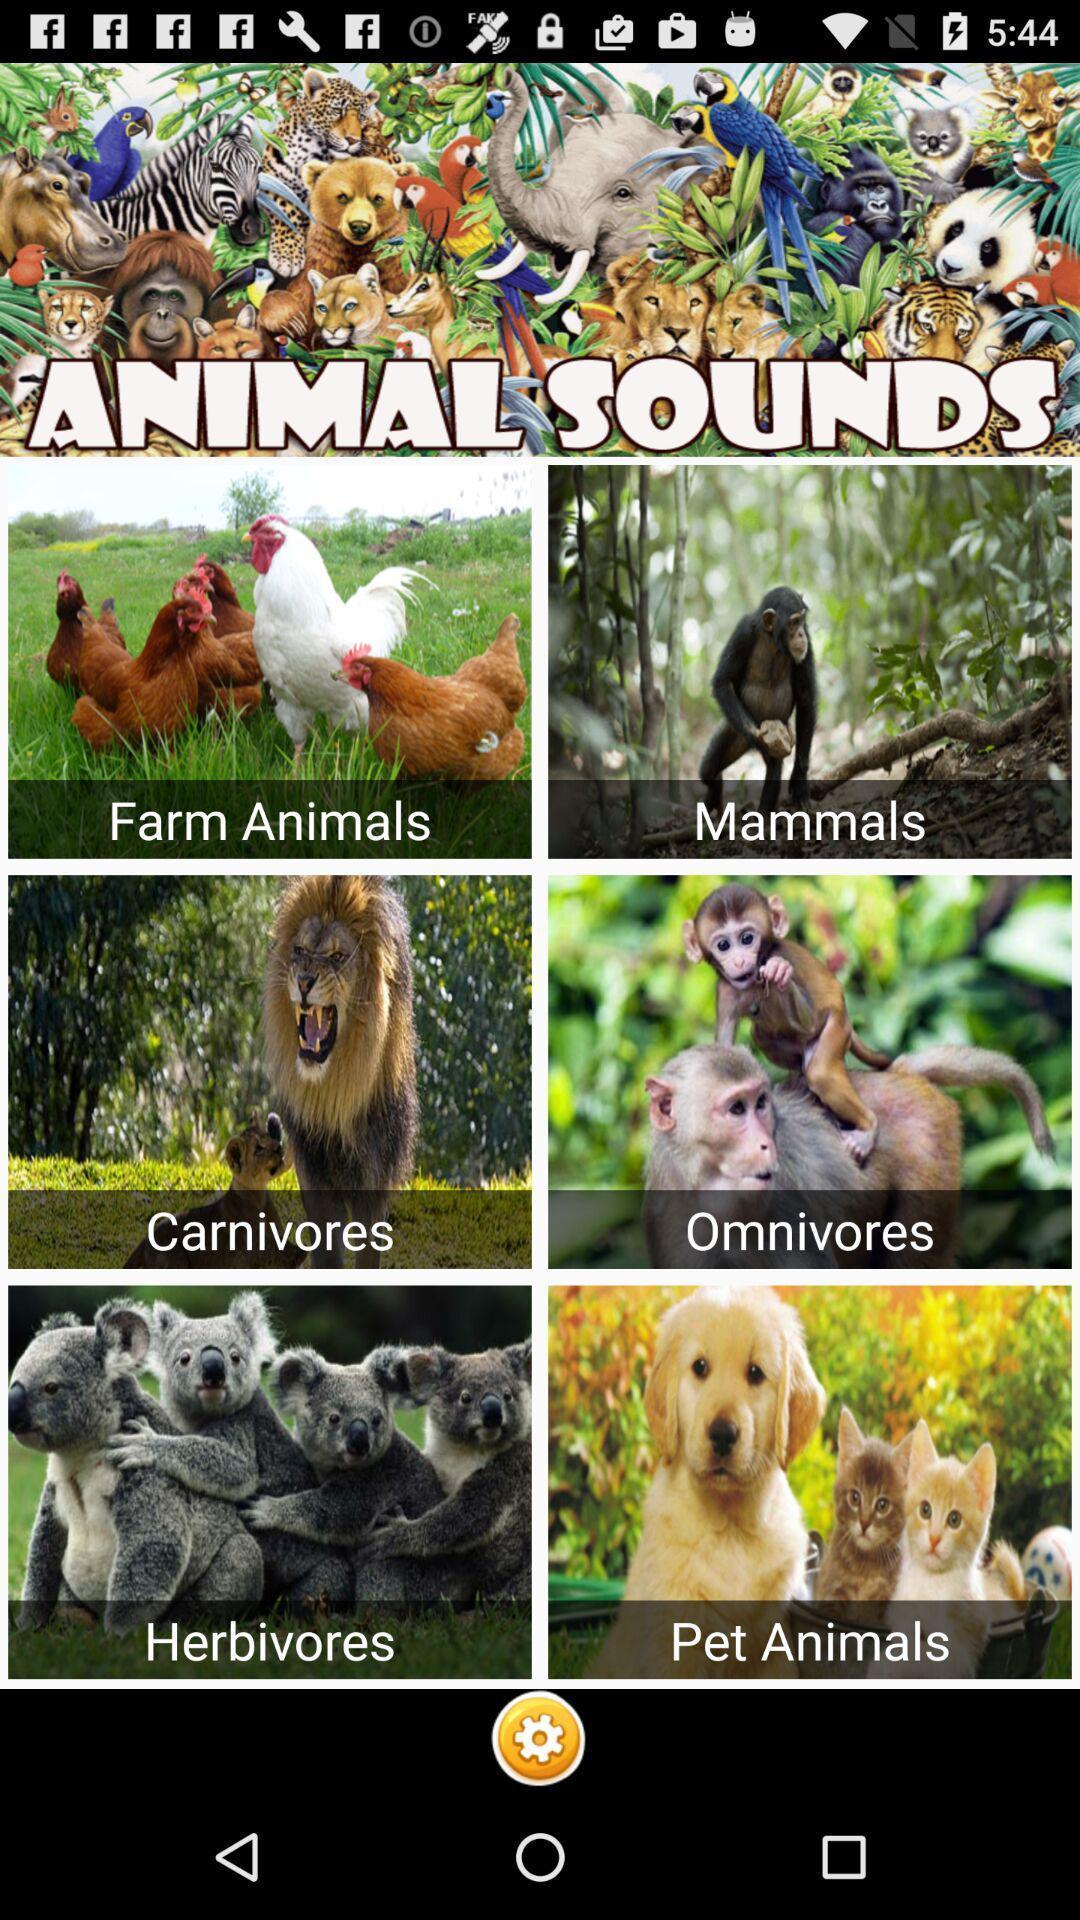What is the overall content of this screenshot? Page shows the various animals pictures on learning app. 